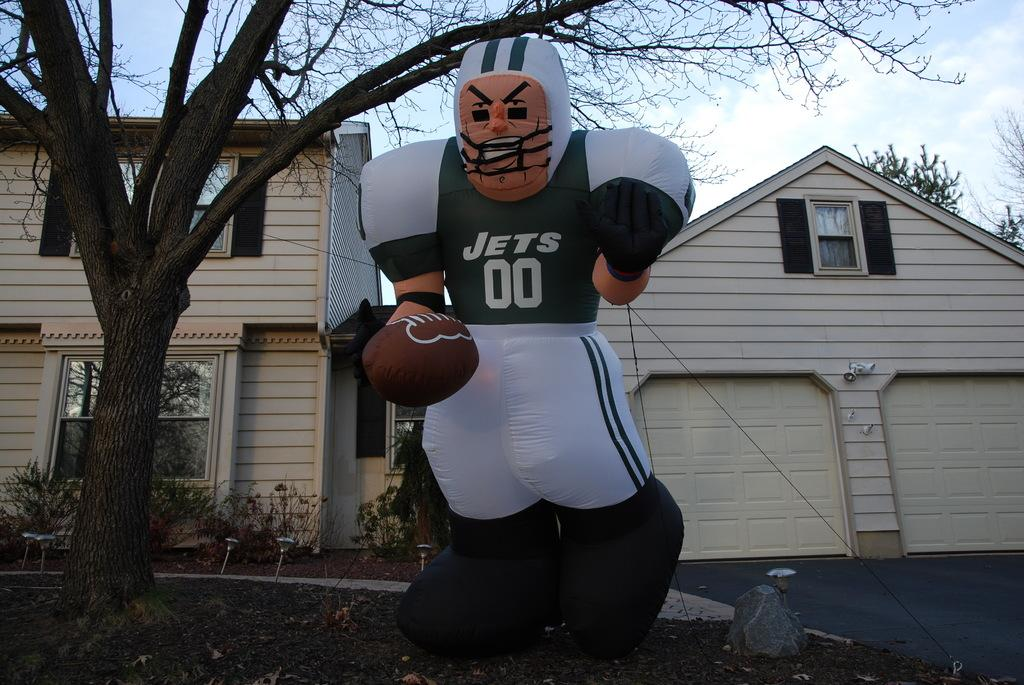<image>
Share a concise interpretation of the image provided. A blow up doll with the words Jets and the number 00 on his chest hangs from a tree. 